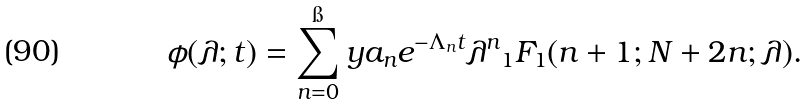Convert formula to latex. <formula><loc_0><loc_0><loc_500><loc_500>\phi ( \lambda ; t ) = \sum _ { n = 0 } ^ { \i } y a _ { n } e ^ { - \Lambda _ { n } t } \lambda ^ { n } { _ { 1 } F _ { 1 } } ( n + 1 ; N + 2 n ; \lambda ) .</formula> 